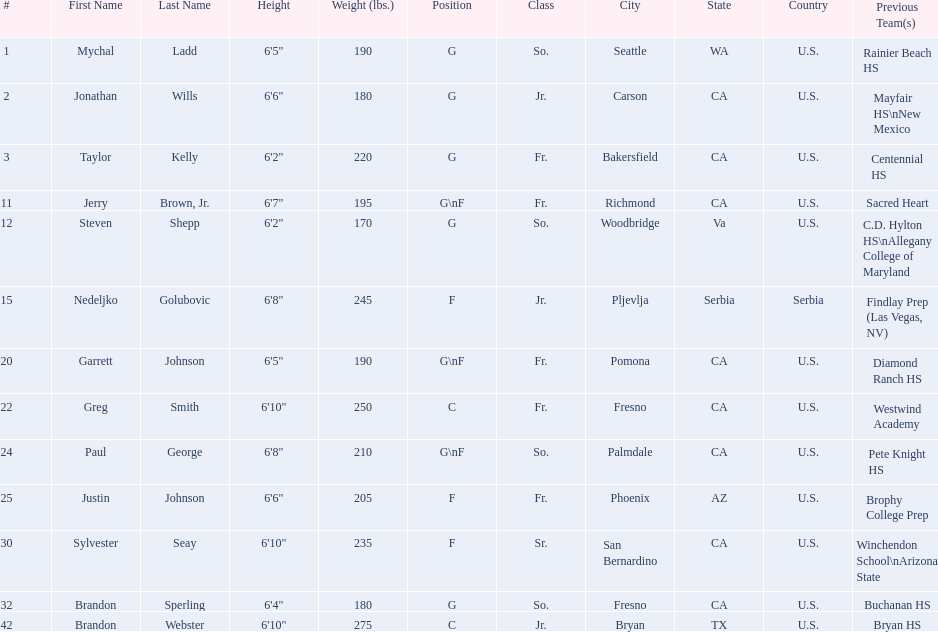What are the names of the basketball team players? Mychal Ladd, Jonathan Wills, Taylor Kelly, Jerry Brown, Jr., Steven Shepp, Nedeljko Golubovic, Garrett Johnson, Greg Smith, Paul George, Justin Johnson, Sylvester Seay, Brandon Sperling, Brandon Webster. Of these identify paul george and greg smith Greg Smith, Paul George. What are their corresponding heights? 6'10", 6'8". To who does the larger height correspond to? Greg Smith. 